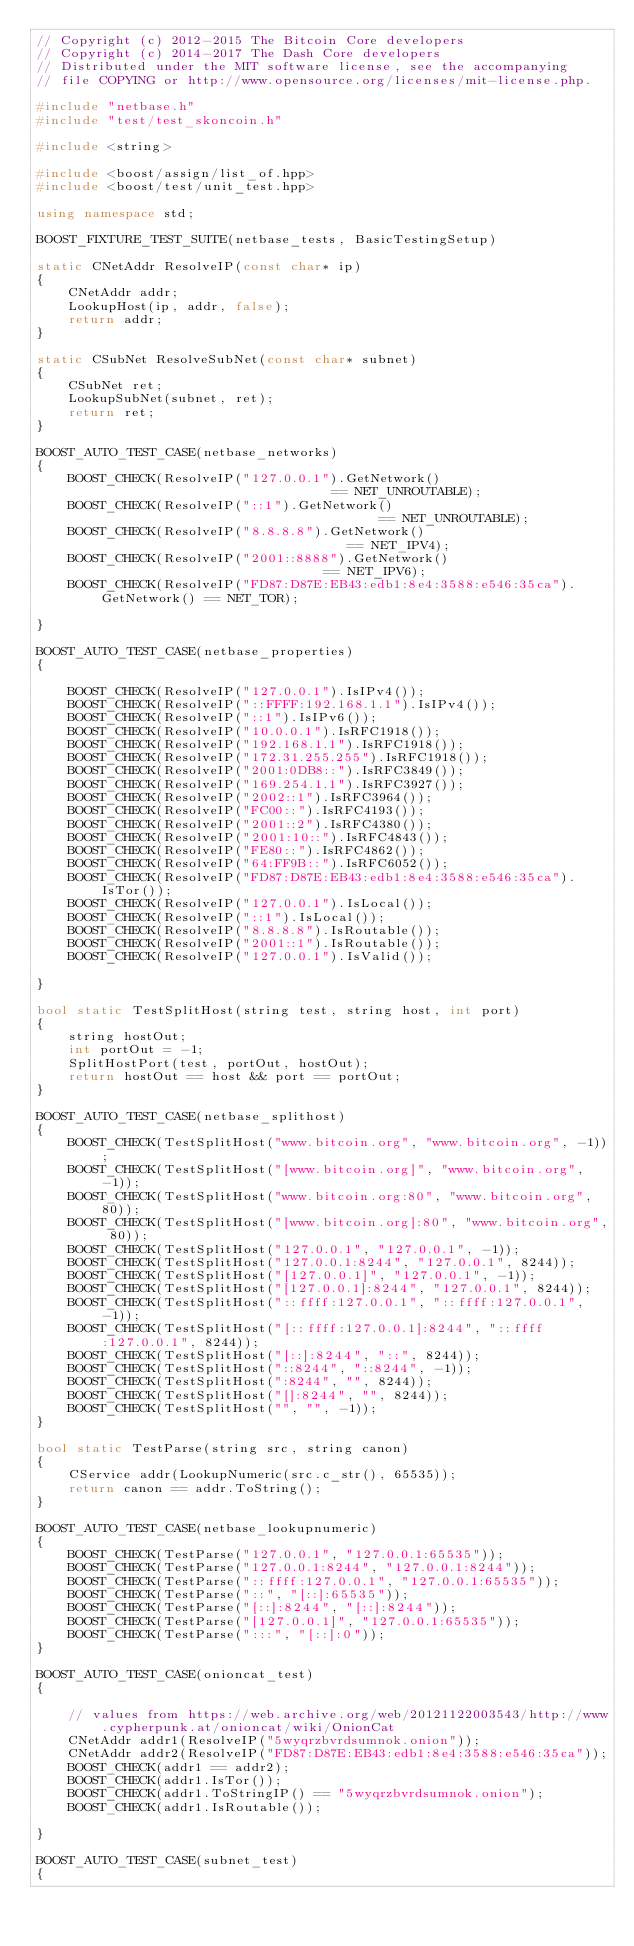Convert code to text. <code><loc_0><loc_0><loc_500><loc_500><_C++_>// Copyright (c) 2012-2015 The Bitcoin Core developers
// Copyright (c) 2014-2017 The Dash Core developers
// Distributed under the MIT software license, see the accompanying
// file COPYING or http://www.opensource.org/licenses/mit-license.php.

#include "netbase.h"
#include "test/test_skoncoin.h"

#include <string>

#include <boost/assign/list_of.hpp>
#include <boost/test/unit_test.hpp>

using namespace std;

BOOST_FIXTURE_TEST_SUITE(netbase_tests, BasicTestingSetup)

static CNetAddr ResolveIP(const char* ip)
{
    CNetAddr addr;
    LookupHost(ip, addr, false);
    return addr;
}

static CSubNet ResolveSubNet(const char* subnet)
{
    CSubNet ret;
    LookupSubNet(subnet, ret);
    return ret;
}

BOOST_AUTO_TEST_CASE(netbase_networks)
{
    BOOST_CHECK(ResolveIP("127.0.0.1").GetNetwork()                              == NET_UNROUTABLE);
    BOOST_CHECK(ResolveIP("::1").GetNetwork()                                    == NET_UNROUTABLE);
    BOOST_CHECK(ResolveIP("8.8.8.8").GetNetwork()                                == NET_IPV4);
    BOOST_CHECK(ResolveIP("2001::8888").GetNetwork()                             == NET_IPV6);
    BOOST_CHECK(ResolveIP("FD87:D87E:EB43:edb1:8e4:3588:e546:35ca").GetNetwork() == NET_TOR);

}

BOOST_AUTO_TEST_CASE(netbase_properties)
{

    BOOST_CHECK(ResolveIP("127.0.0.1").IsIPv4());
    BOOST_CHECK(ResolveIP("::FFFF:192.168.1.1").IsIPv4());
    BOOST_CHECK(ResolveIP("::1").IsIPv6());
    BOOST_CHECK(ResolveIP("10.0.0.1").IsRFC1918());
    BOOST_CHECK(ResolveIP("192.168.1.1").IsRFC1918());
    BOOST_CHECK(ResolveIP("172.31.255.255").IsRFC1918());
    BOOST_CHECK(ResolveIP("2001:0DB8::").IsRFC3849());
    BOOST_CHECK(ResolveIP("169.254.1.1").IsRFC3927());
    BOOST_CHECK(ResolveIP("2002::1").IsRFC3964());
    BOOST_CHECK(ResolveIP("FC00::").IsRFC4193());
    BOOST_CHECK(ResolveIP("2001::2").IsRFC4380());
    BOOST_CHECK(ResolveIP("2001:10::").IsRFC4843());
    BOOST_CHECK(ResolveIP("FE80::").IsRFC4862());
    BOOST_CHECK(ResolveIP("64:FF9B::").IsRFC6052());
    BOOST_CHECK(ResolveIP("FD87:D87E:EB43:edb1:8e4:3588:e546:35ca").IsTor());
    BOOST_CHECK(ResolveIP("127.0.0.1").IsLocal());
    BOOST_CHECK(ResolveIP("::1").IsLocal());
    BOOST_CHECK(ResolveIP("8.8.8.8").IsRoutable());
    BOOST_CHECK(ResolveIP("2001::1").IsRoutable());
    BOOST_CHECK(ResolveIP("127.0.0.1").IsValid());

}

bool static TestSplitHost(string test, string host, int port)
{
    string hostOut;
    int portOut = -1;
    SplitHostPort(test, portOut, hostOut);
    return hostOut == host && port == portOut;
}

BOOST_AUTO_TEST_CASE(netbase_splithost)
{
    BOOST_CHECK(TestSplitHost("www.bitcoin.org", "www.bitcoin.org", -1));
    BOOST_CHECK(TestSplitHost("[www.bitcoin.org]", "www.bitcoin.org", -1));
    BOOST_CHECK(TestSplitHost("www.bitcoin.org:80", "www.bitcoin.org", 80));
    BOOST_CHECK(TestSplitHost("[www.bitcoin.org]:80", "www.bitcoin.org", 80));
    BOOST_CHECK(TestSplitHost("127.0.0.1", "127.0.0.1", -1));
    BOOST_CHECK(TestSplitHost("127.0.0.1:8244", "127.0.0.1", 8244));
    BOOST_CHECK(TestSplitHost("[127.0.0.1]", "127.0.0.1", -1));
    BOOST_CHECK(TestSplitHost("[127.0.0.1]:8244", "127.0.0.1", 8244));
    BOOST_CHECK(TestSplitHost("::ffff:127.0.0.1", "::ffff:127.0.0.1", -1));
    BOOST_CHECK(TestSplitHost("[::ffff:127.0.0.1]:8244", "::ffff:127.0.0.1", 8244));
    BOOST_CHECK(TestSplitHost("[::]:8244", "::", 8244));
    BOOST_CHECK(TestSplitHost("::8244", "::8244", -1));
    BOOST_CHECK(TestSplitHost(":8244", "", 8244));
    BOOST_CHECK(TestSplitHost("[]:8244", "", 8244));
    BOOST_CHECK(TestSplitHost("", "", -1));
}

bool static TestParse(string src, string canon)
{
    CService addr(LookupNumeric(src.c_str(), 65535));
    return canon == addr.ToString();
}

BOOST_AUTO_TEST_CASE(netbase_lookupnumeric)
{
    BOOST_CHECK(TestParse("127.0.0.1", "127.0.0.1:65535"));
    BOOST_CHECK(TestParse("127.0.0.1:8244", "127.0.0.1:8244"));
    BOOST_CHECK(TestParse("::ffff:127.0.0.1", "127.0.0.1:65535"));
    BOOST_CHECK(TestParse("::", "[::]:65535"));
    BOOST_CHECK(TestParse("[::]:8244", "[::]:8244"));
    BOOST_CHECK(TestParse("[127.0.0.1]", "127.0.0.1:65535"));
    BOOST_CHECK(TestParse(":::", "[::]:0"));
}

BOOST_AUTO_TEST_CASE(onioncat_test)
{

    // values from https://web.archive.org/web/20121122003543/http://www.cypherpunk.at/onioncat/wiki/OnionCat
    CNetAddr addr1(ResolveIP("5wyqrzbvrdsumnok.onion"));
    CNetAddr addr2(ResolveIP("FD87:D87E:EB43:edb1:8e4:3588:e546:35ca"));
    BOOST_CHECK(addr1 == addr2);
    BOOST_CHECK(addr1.IsTor());
    BOOST_CHECK(addr1.ToStringIP() == "5wyqrzbvrdsumnok.onion");
    BOOST_CHECK(addr1.IsRoutable());

}

BOOST_AUTO_TEST_CASE(subnet_test)
{
</code> 